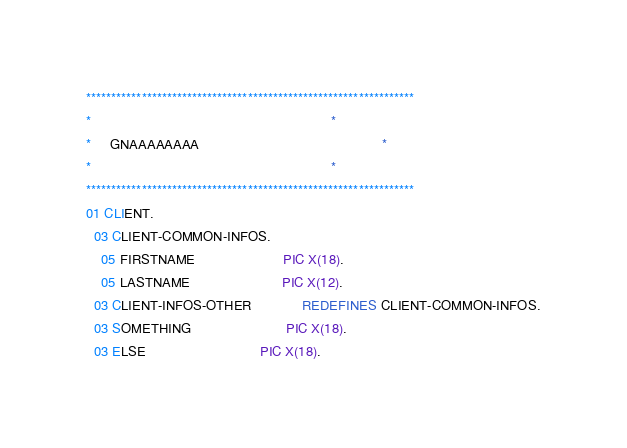<code> <loc_0><loc_0><loc_500><loc_500><_COBOL_>*****************************************************************
*                                                               *
*     GNAAAAAAAA                                                *
*                                                               *
*****************************************************************
01 CLIENT.
  03 CLIENT-COMMON-INFOS.
    05 FIRSTNAME                       PIC X(18).
    05 LASTNAME                        PIC X(12).
  03 CLIENT-INFOS-OTHER             REDEFINES CLIENT-COMMON-INFOS.
  03 SOMETHING                         PIC X(18).
  03 ELSE                              PIC X(18).
</code> 